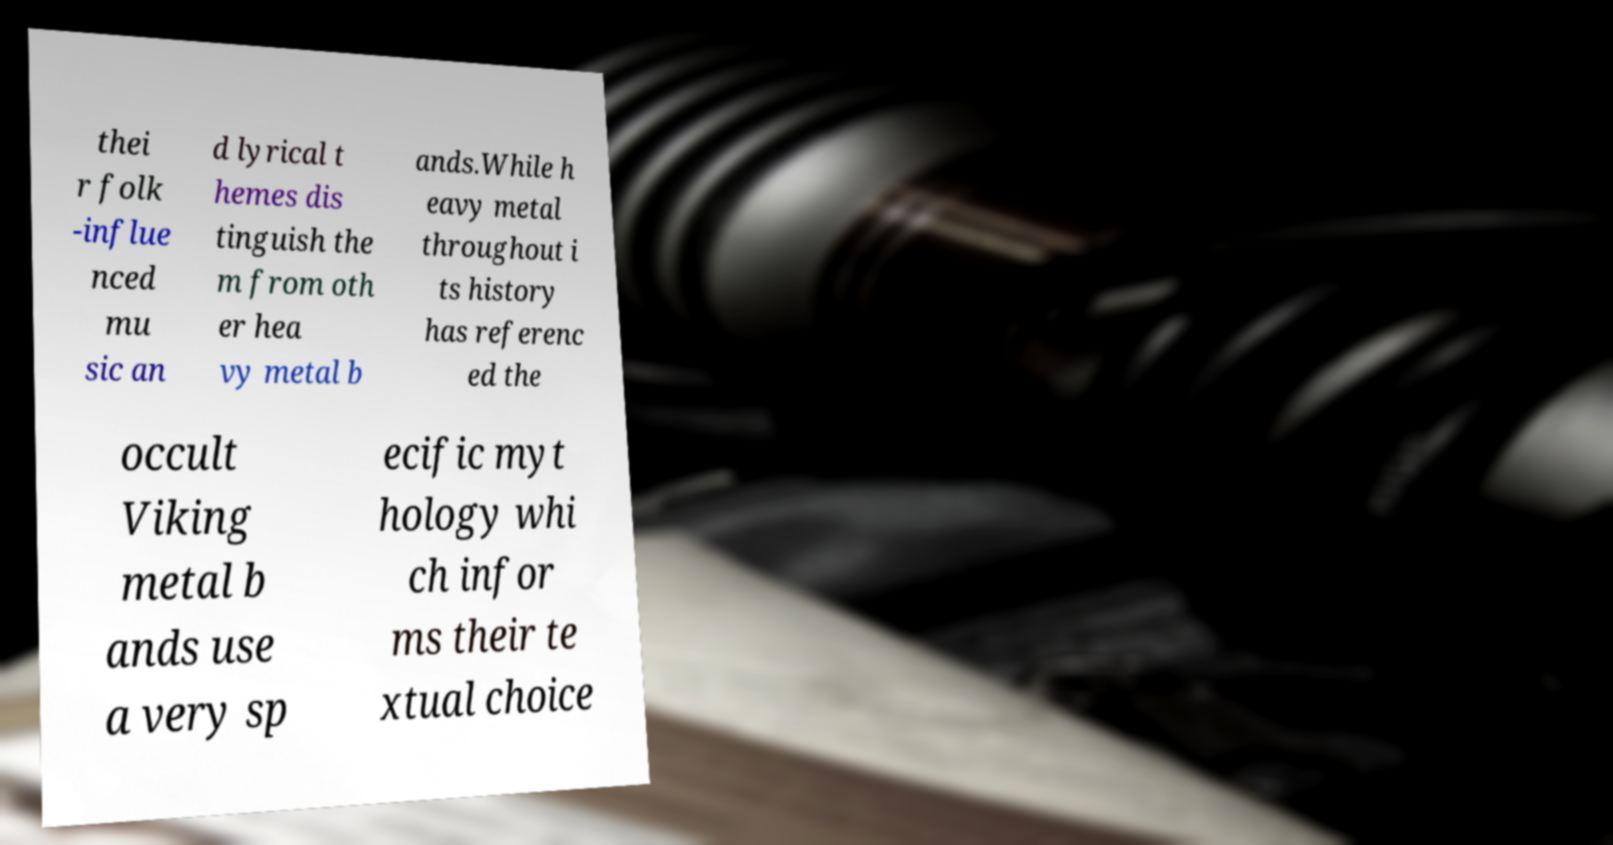I need the written content from this picture converted into text. Can you do that? thei r folk -influe nced mu sic an d lyrical t hemes dis tinguish the m from oth er hea vy metal b ands.While h eavy metal throughout i ts history has referenc ed the occult Viking metal b ands use a very sp ecific myt hology whi ch infor ms their te xtual choice 